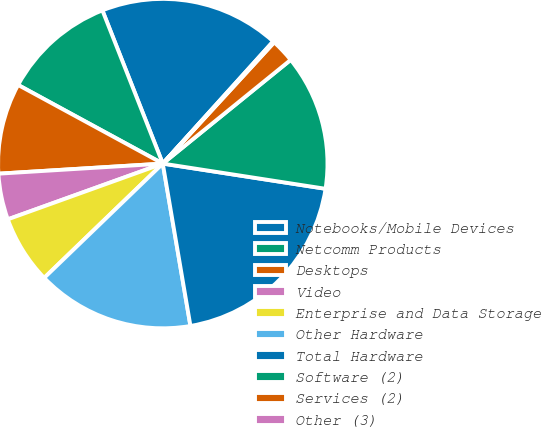Convert chart to OTSL. <chart><loc_0><loc_0><loc_500><loc_500><pie_chart><fcel>Notebooks/Mobile Devices<fcel>Netcomm Products<fcel>Desktops<fcel>Video<fcel>Enterprise and Data Storage<fcel>Other Hardware<fcel>Total Hardware<fcel>Software (2)<fcel>Services (2)<fcel>Other (3)<nl><fcel>17.67%<fcel>11.1%<fcel>8.9%<fcel>4.52%<fcel>6.71%<fcel>15.48%<fcel>19.87%<fcel>13.29%<fcel>2.33%<fcel>0.13%<nl></chart> 